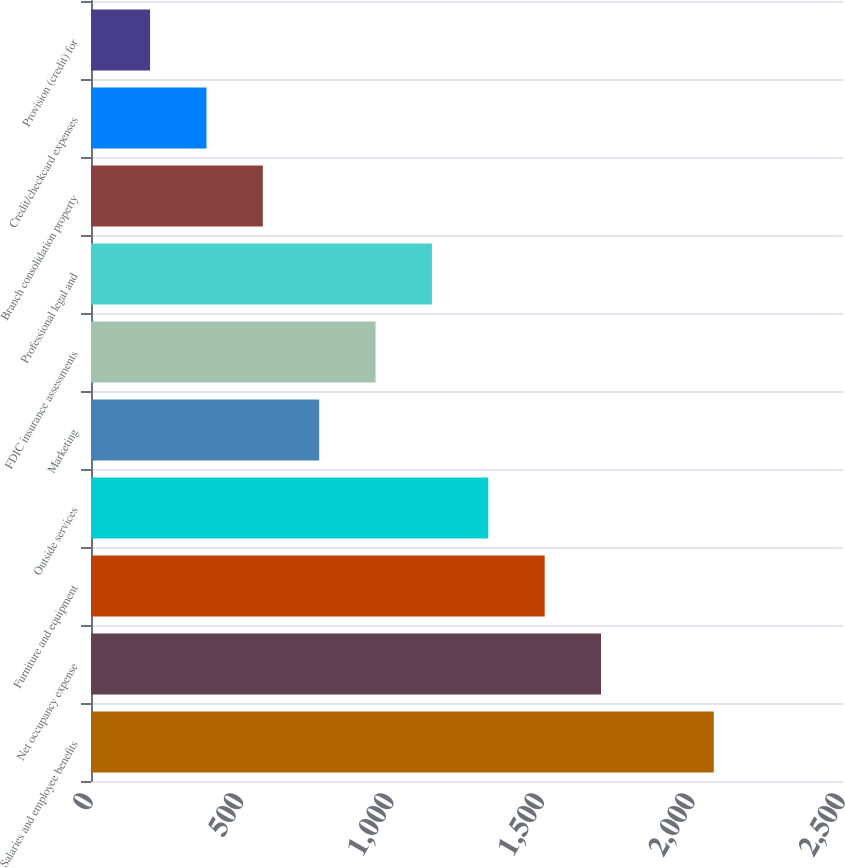<chart> <loc_0><loc_0><loc_500><loc_500><bar_chart><fcel>Salaries and employee benefits<fcel>Net occupancy expense<fcel>Furniture and equipment<fcel>Outside services<fcel>Marketing<fcel>FDIC insurance assessments<fcel>Professional legal and<fcel>Branch consolidation property<fcel>Credit/checkcard expenses<fcel>Provision (credit) for<nl><fcel>2070.4<fcel>1695.6<fcel>1508.2<fcel>1320.8<fcel>758.6<fcel>946<fcel>1133.4<fcel>571.2<fcel>383.8<fcel>196.4<nl></chart> 